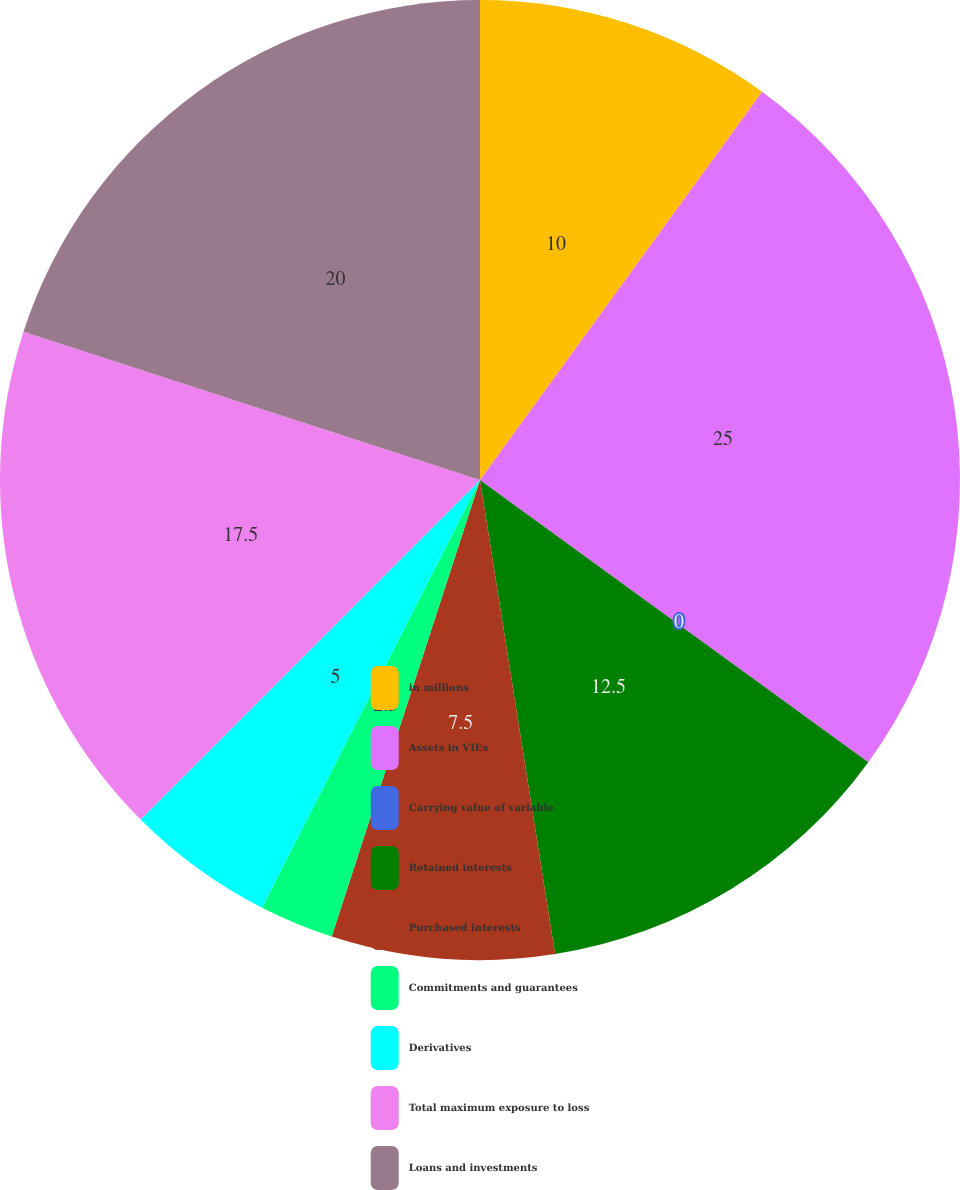<chart> <loc_0><loc_0><loc_500><loc_500><pie_chart><fcel>in millions<fcel>Assets in VIEs<fcel>Carrying value of variable<fcel>Retained interests<fcel>Purchased interests<fcel>Commitments and guarantees<fcel>Derivatives<fcel>Total maximum exposure to loss<fcel>Loans and investments<nl><fcel>10.0%<fcel>25.0%<fcel>0.0%<fcel>12.5%<fcel>7.5%<fcel>2.5%<fcel>5.0%<fcel>17.5%<fcel>20.0%<nl></chart> 